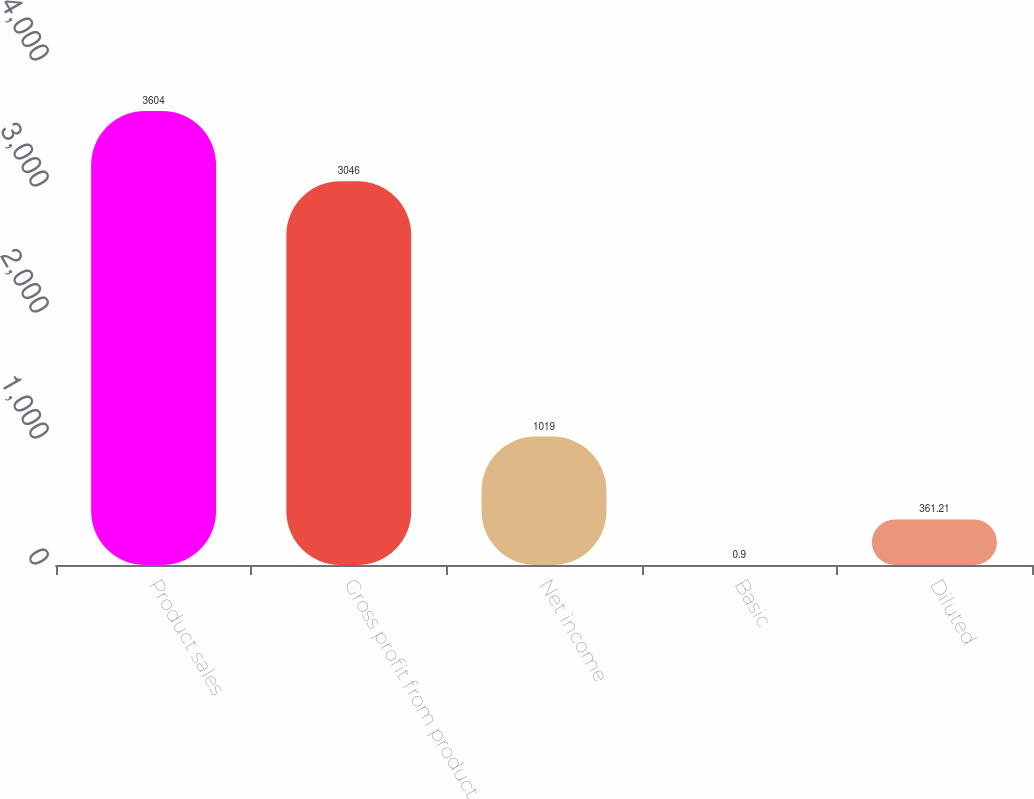Convert chart to OTSL. <chart><loc_0><loc_0><loc_500><loc_500><bar_chart><fcel>Product sales<fcel>Gross profit from product<fcel>Net income<fcel>Basic<fcel>Diluted<nl><fcel>3604<fcel>3046<fcel>1019<fcel>0.9<fcel>361.21<nl></chart> 